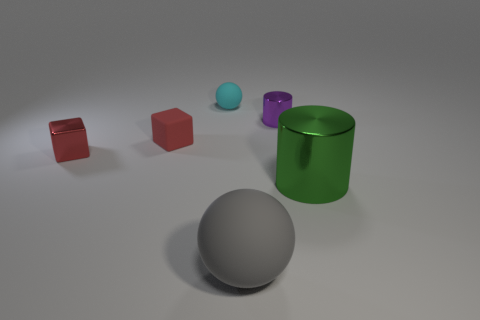Do the rubber block and the cyan matte ball have the same size?
Make the answer very short. Yes. What number of objects are shiny things that are to the right of the shiny block or balls in front of the big shiny cylinder?
Offer a very short reply. 3. There is a red thing that is in front of the small red thing right of the metal block; what number of small cyan rubber objects are on the left side of it?
Offer a terse response. 0. What is the size of the ball that is right of the tiny sphere?
Provide a succinct answer. Large. How many matte cubes are the same size as the red shiny thing?
Your answer should be very brief. 1. There is a purple metallic object; is its size the same as the matte ball behind the big ball?
Give a very brief answer. Yes. What number of objects are big green shiny cylinders or blue matte things?
Give a very brief answer. 1. How many small things have the same color as the small shiny cube?
Provide a short and direct response. 1. There is a cyan matte object that is the same size as the red metallic thing; what shape is it?
Provide a short and direct response. Sphere. Are there any other metallic objects of the same shape as the large green object?
Give a very brief answer. Yes. 